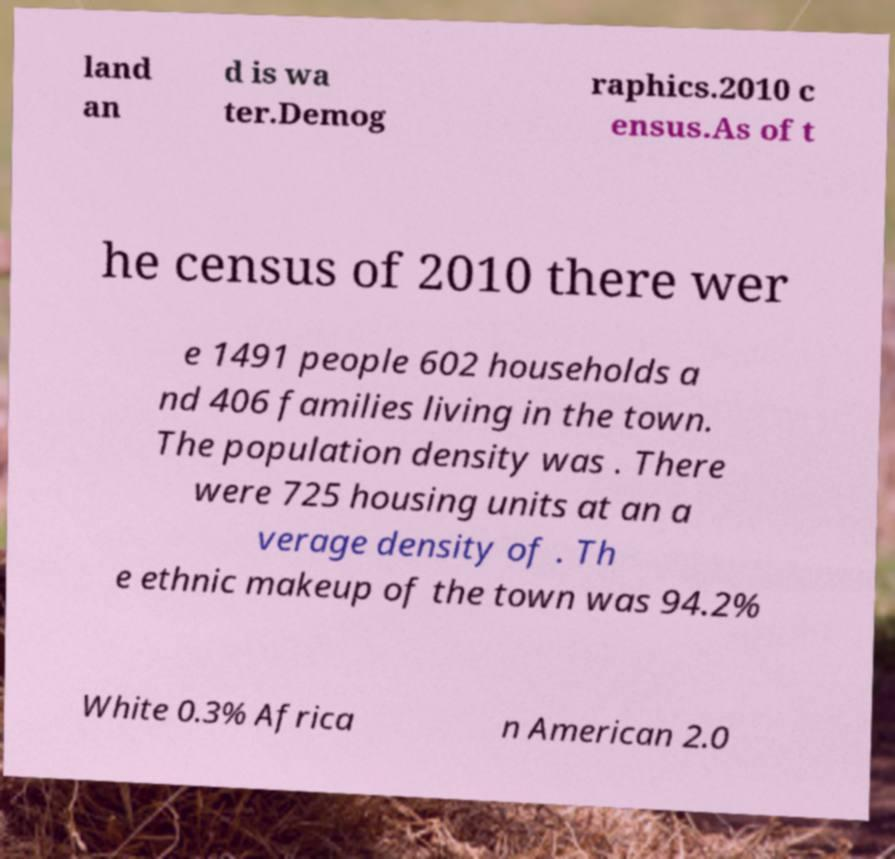Please identify and transcribe the text found in this image. land an d is wa ter.Demog raphics.2010 c ensus.As of t he census of 2010 there wer e 1491 people 602 households a nd 406 families living in the town. The population density was . There were 725 housing units at an a verage density of . Th e ethnic makeup of the town was 94.2% White 0.3% Africa n American 2.0 